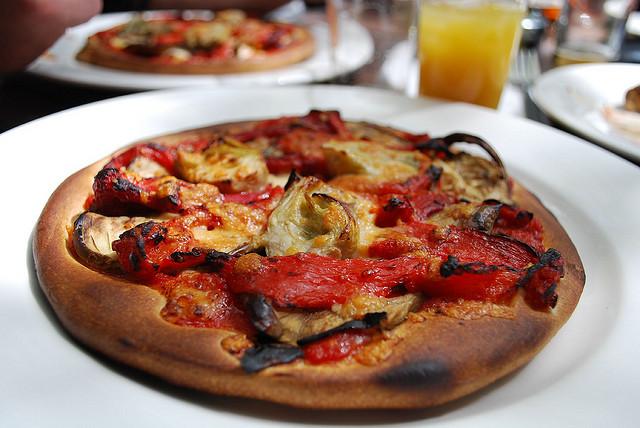What toppings are on this pizza?
Quick response, please. Tomatoes. How many pizzas are shown?
Keep it brief. 2. Is any of the pizza burnt?
Keep it brief. Yes. 